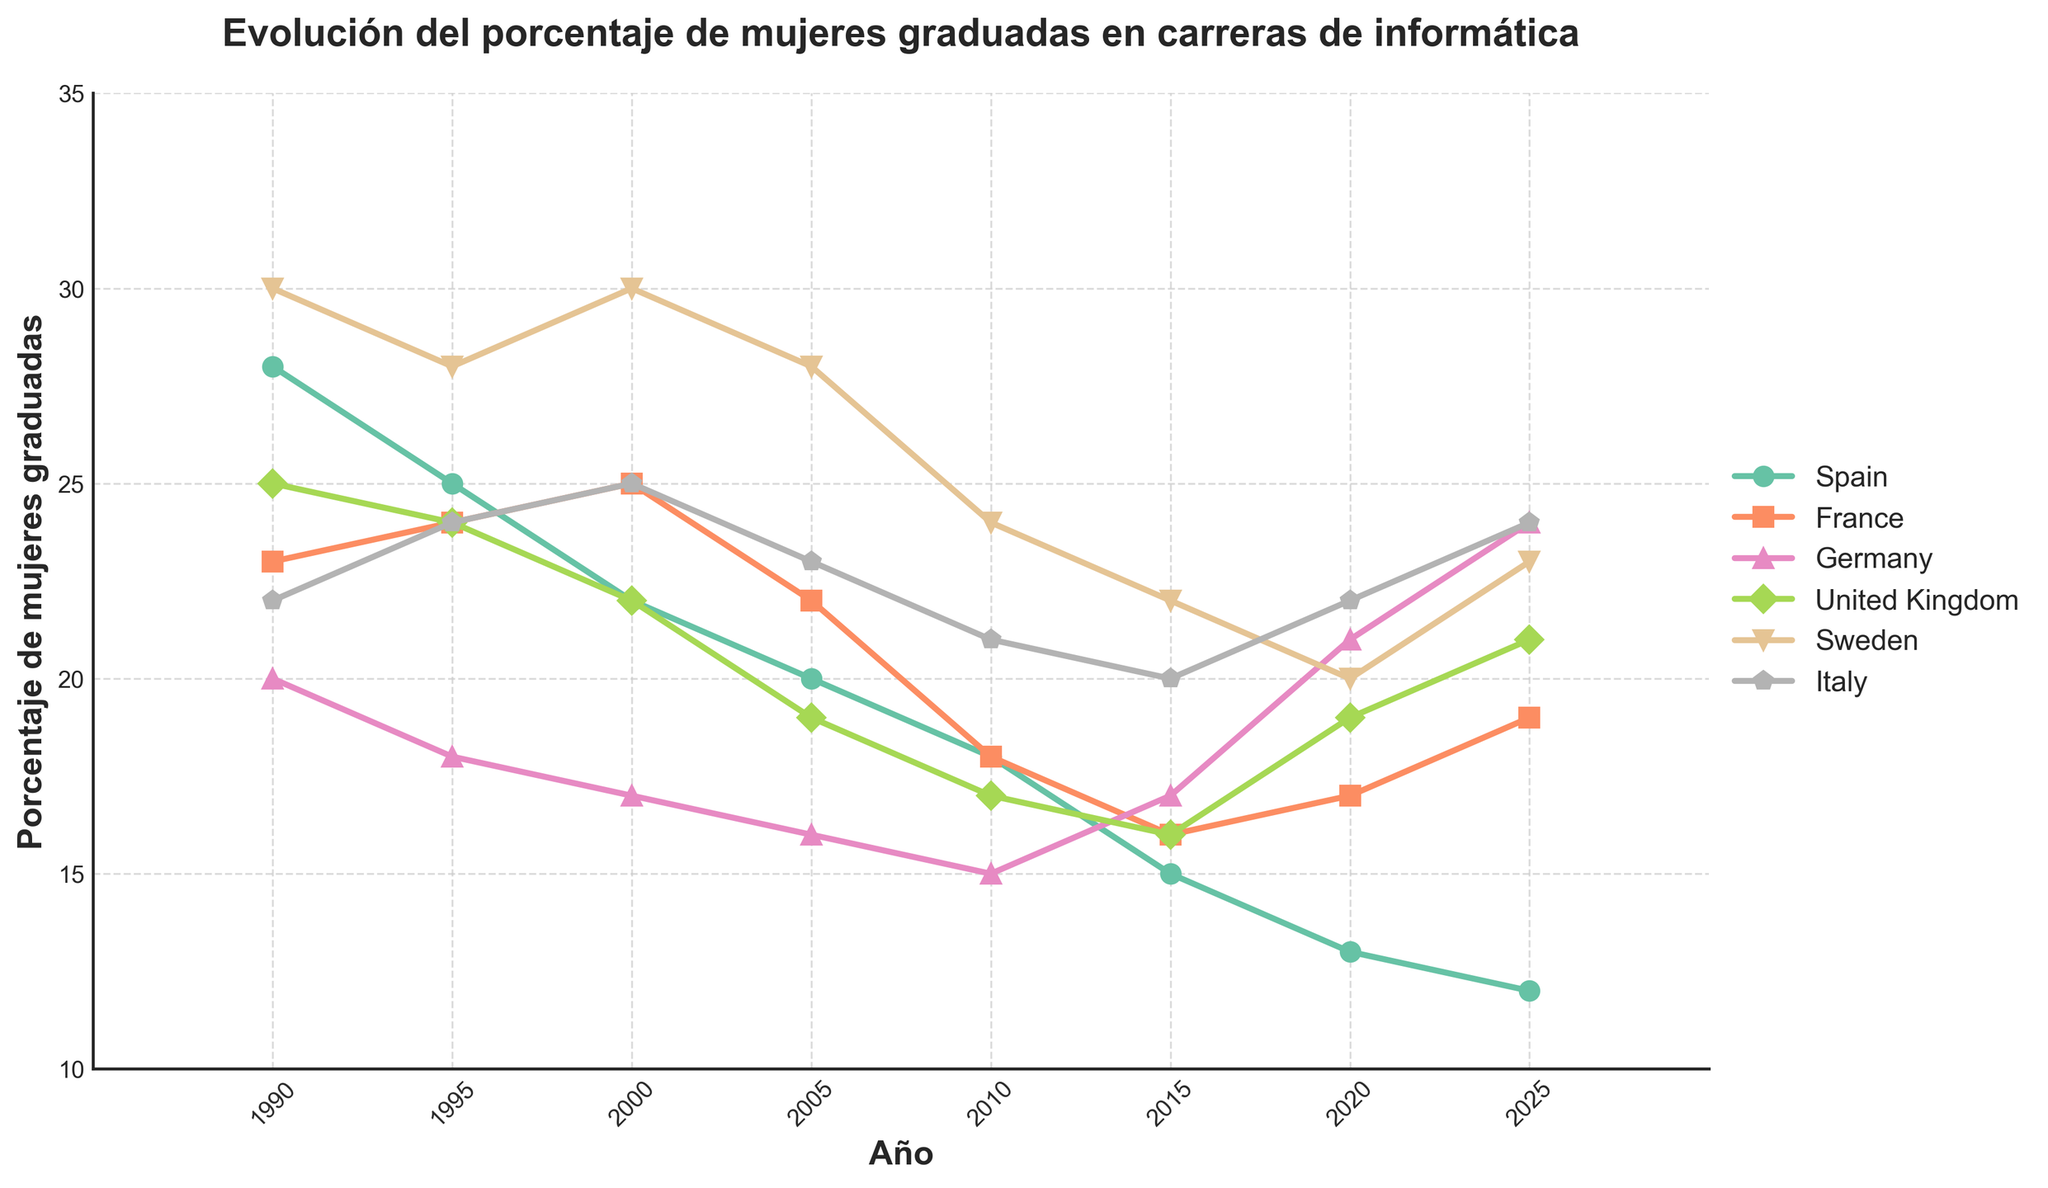¿Cuál fue el país con el mayor porcentaje de mujeres graduadas en informática en 1990? Observando la línea del año 1990 en el gráfico, el país con el porcentaje más alto es Suecia con un 30%.
Answer: Suecia ¿Entre 1990 y 2025, qué país mostró la mayor disminución en el porcentaje de mujeres graduadas en informática? Comparando las líneas desde 1990 hasta 2025, España pasó de 28% a 12%, lo que representa la mayor disminución.
Answer: España ¿Cuál es el porcentaje promedio de mujeres graduadas en informática en Italia durante el periodo mostrado? Sumamos los porcentajes de Italia (22, 24, 25, 23, 21, 20, 22, 24) y luego dividimos entre el número de puntos (8). El cálculo es (22+24+25+23+21+20+22+24) / 8 = 22.625.
Answer: 22.625% En el año 2020, ¿qué país tenía el menor porcentaje de mujeres graduadas en informática? Revisando el gráfico para el año 2020, el país con el valor más bajo es España con un 13%.
Answer: España ¿Cómo se compara la tendencia de Francia con la de Alemania entre 1990 y 2025? Francia muestra una tendencia fluctuante pero ligeramente ascendente, mientras que la tendencia de Alemania es ascendente y más pronunciada. Francia comienza en 23% y termina en 19%, mientras que Alemania aumenta de 20% a 24%.
Answer: Alemania muestra una mayor subida ¿Cuál fue el cambio en el porcentaje de mujeres graduadas en informática en Suecia entre 1990 y 2025? En 1990, Suecia tenía un 30% y en 2025 un 23%. El cambio es 30% - 23% = 7%.
Answer: Disminución de 7% En 2015, ¿qué país tenía un porcentaje superior al de Suecia? En 2015, Francia (16%), Alemania (17%), Reino Unido (16%) e Italia (20%) están por debajo o igual que Suecia (22%), por lo que ninguno tiene un porcentaje superior.
Answer: Ninguno ¿Cuál es la diferencia promedio en el porcentaje de graduadas entre España y Reino Unido a lo largo de los años graficados? Restamos los valores respectivos de España y Reino Unido para cada año: (28-25, 25-24, 22-22, 20-19, 18-17, 15-16, 13-19, 12-21) = (3, 1, 0, 1, 1, -1, -6, -9). Luego promediamos estas diferencias: (3+1+0+1+1-1-6-9) / 8 = -1.375.
Answer: -1.375% De 1990 a 2010, ¿qué país experimentó menos variación en el porcentaje de mujeres graduadas en informática? Calculamos la diferencia máxima y mínima en cada país durante este periodo. Suecia varía de 30% a 24%, España de 28% a 18%, Francia de 23% a 18%, Alemania de 20% a 15%, Reino Unido de 25% a 17%, e Italia de 22% a 21%. La menor variación es Italia, con un cambio de solo 2%.
Answer: Italia 